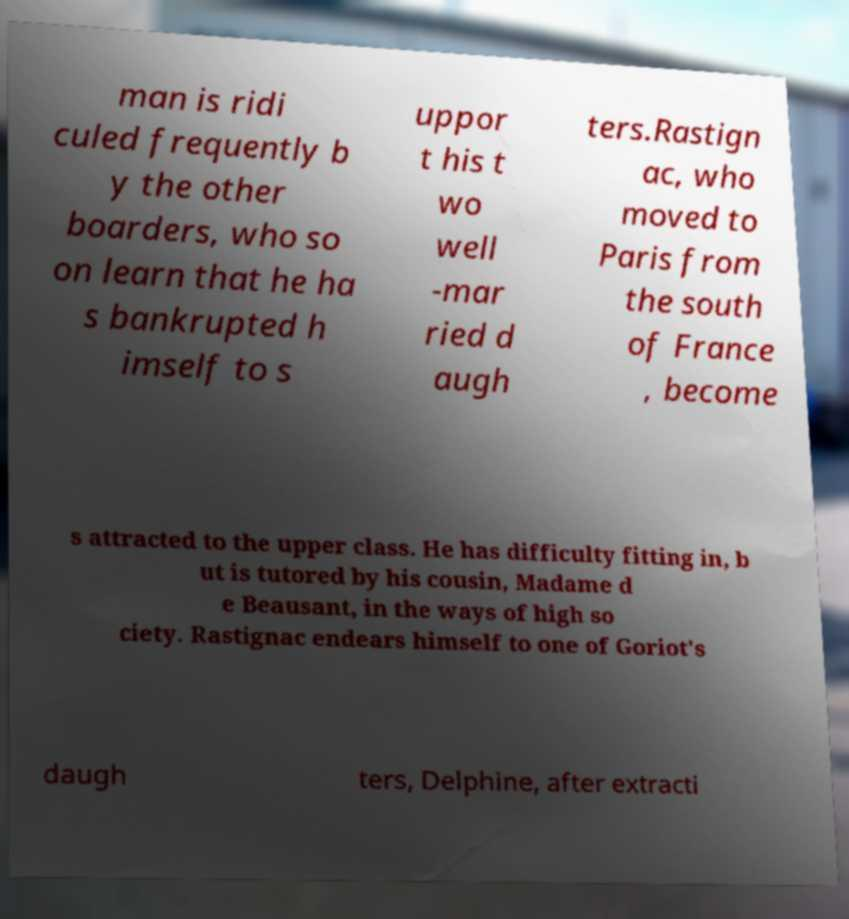Can you accurately transcribe the text from the provided image for me? man is ridi culed frequently b y the other boarders, who so on learn that he ha s bankrupted h imself to s uppor t his t wo well -mar ried d augh ters.Rastign ac, who moved to Paris from the south of France , become s attracted to the upper class. He has difficulty fitting in, b ut is tutored by his cousin, Madame d e Beausant, in the ways of high so ciety. Rastignac endears himself to one of Goriot's daugh ters, Delphine, after extracti 